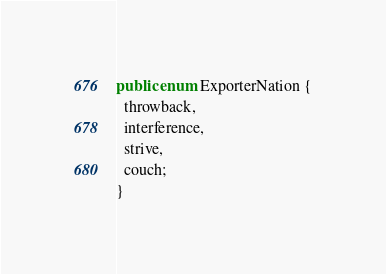Convert code to text. <code><loc_0><loc_0><loc_500><loc_500><_Java_>
public enum ExporterNation {
  throwback,
  interference,
  strive,
  couch;
}
</code> 